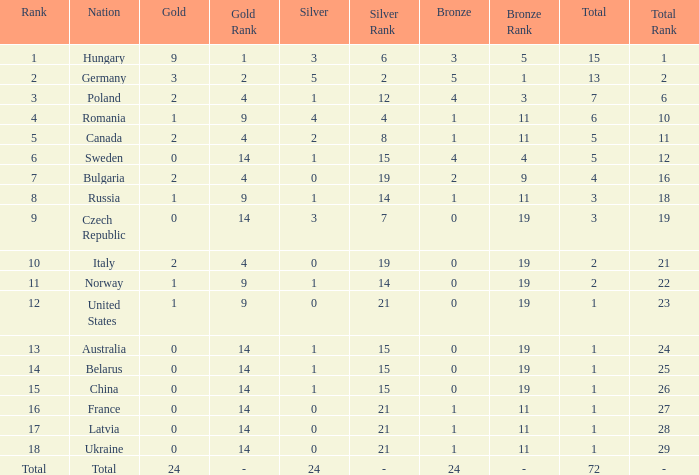What average silver has belarus as the nation, with a total less than 1? None. 